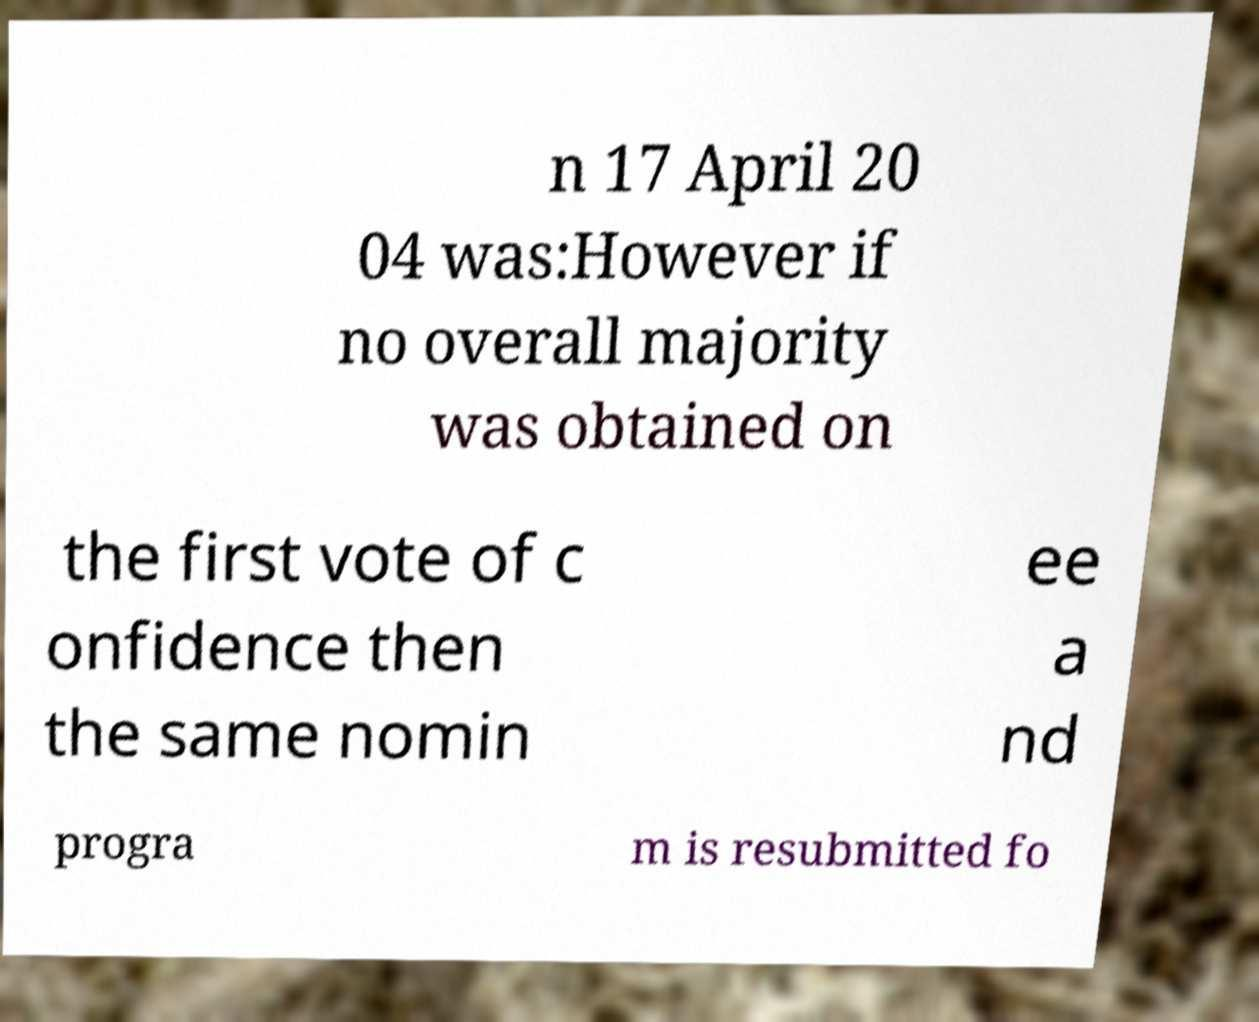Please identify and transcribe the text found in this image. n 17 April 20 04 was:However if no overall majority was obtained on the first vote of c onfidence then the same nomin ee a nd progra m is resubmitted fo 